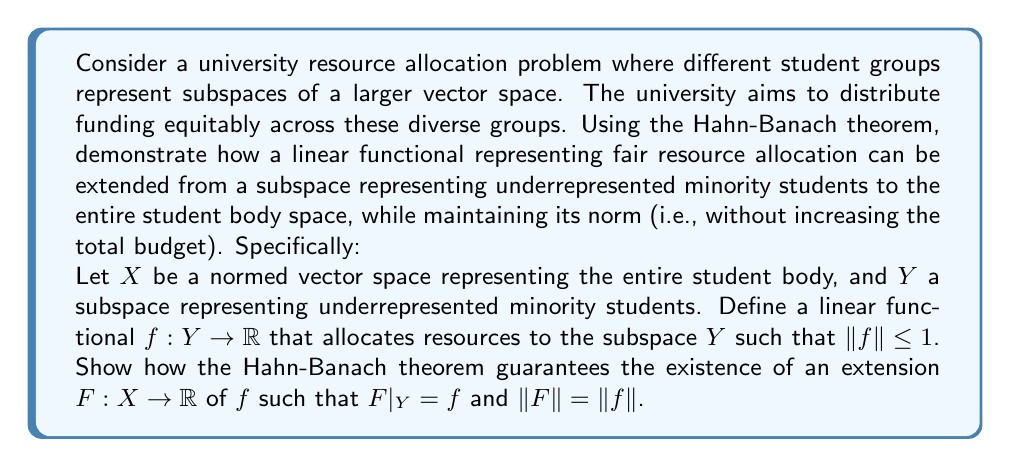Give your solution to this math problem. To solve this problem, we'll apply the Hahn-Banach theorem and break down the solution into steps:

1) First, recall the Hahn-Banach theorem: Let $X$ be a real vector space and $p$ a sublinear functional on $X$. If $Y$ is a subspace of $X$ and $f: Y \to \mathbb{R}$ is a linear functional such that $f(y) \leq p(y)$ for all $y \in Y$, then there exists a linear extension $F: X \to \mathbb{R}$ of $f$ such that $F(x) \leq p(x)$ for all $x \in X$.

2) In our case, we need to define a suitable sublinear functional $p$ on $X$. Given that $\|f\| \leq 1$, we can define $p(x) = \|x\|$ for all $x \in X$. This is indeed sublinear as it satisfies:
   
   a) $p(\alpha x) = \|\alpha x\| = |\alpha| \|x\| = |\alpha| p(x)$ for all $\alpha \in \mathbb{R}$ and $x \in X$
   b) $p(x+y) = \|x+y\| \leq \|x\| + \|y\| = p(x) + p(y)$ for all $x,y \in X$

3) Now, we need to verify that $f(y) \leq p(y)$ for all $y \in Y$. This is true because:

   $|f(y)| \leq \|f\| \|y\| \leq \|y\| = p(y)$ for all $y \in Y$

4) Therefore, all conditions of the Hahn-Banach theorem are satisfied. This guarantees the existence of a linear extension $F: X \to \mathbb{R}$ of $f$ such that $F(x) \leq p(x) = \|x\|$ for all $x \in X$.

5) This extension $F$ satisfies:
   
   a) $F|_Y = f$ (it extends $f$)
   b) $\|F\| \leq 1$ (because $|F(x)| \leq \|x\|$ for all $x \in X$)
   c) $\|F\| \geq \|f\|$ (because $F$ is an extension of $f$)

6) Combining (b) and (c), we get $\|F\| = \|f\|$.

Thus, we have shown that the Hahn-Banach theorem guarantees the existence of an extension $F$ of $f$ to the entire space $X$, representing a fair resource allocation to the entire student body, while maintaining the same norm (i.e., without increasing the total budget).
Answer: The Hahn-Banach theorem guarantees the existence of a linear functional $F: X \to \mathbb{R}$ that extends $f: Y \to \mathbb{R}$, such that $F|_Y = f$ and $\|F\| = \|f\| \leq 1$. This extension represents an equitable resource allocation to the entire student body that maintains the fairness established for the underrepresented minority subgroup without increasing the total budget. 